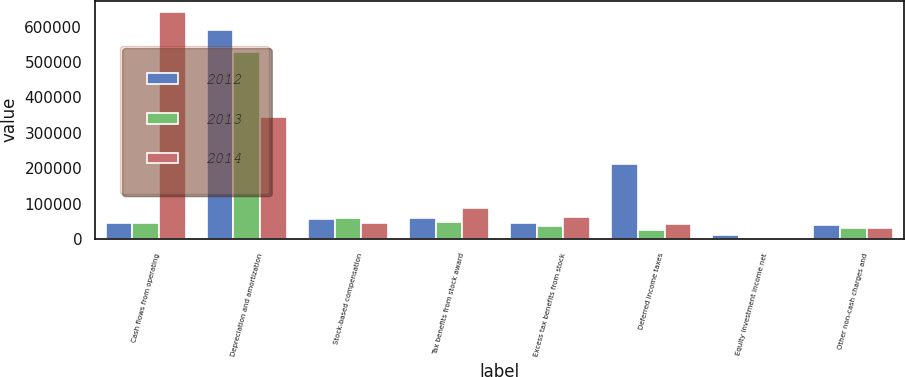Convert chart. <chart><loc_0><loc_0><loc_500><loc_500><stacked_bar_chart><ecel><fcel>Cash flows from operating<fcel>Depreciation and amortization<fcel>Stock-based compensation<fcel>Tax benefits from stock award<fcel>Excess tax benefits from stock<fcel>Deferred income taxes<fcel>Equity investment income net<fcel>Other non-cash charges and<nl><fcel>2012<fcel>46141<fcel>590935<fcel>56743<fcel>59119<fcel>45271<fcel>210955<fcel>10125<fcel>39274<nl><fcel>2013<fcel>46141<fcel>528119<fcel>59998<fcel>46898<fcel>36197<fcel>25380<fcel>2872<fcel>31351<nl><fcel>2014<fcel>641237<fcel>343908<fcel>45384<fcel>88964<fcel>62036<fcel>43765<fcel>3384<fcel>30390<nl></chart> 